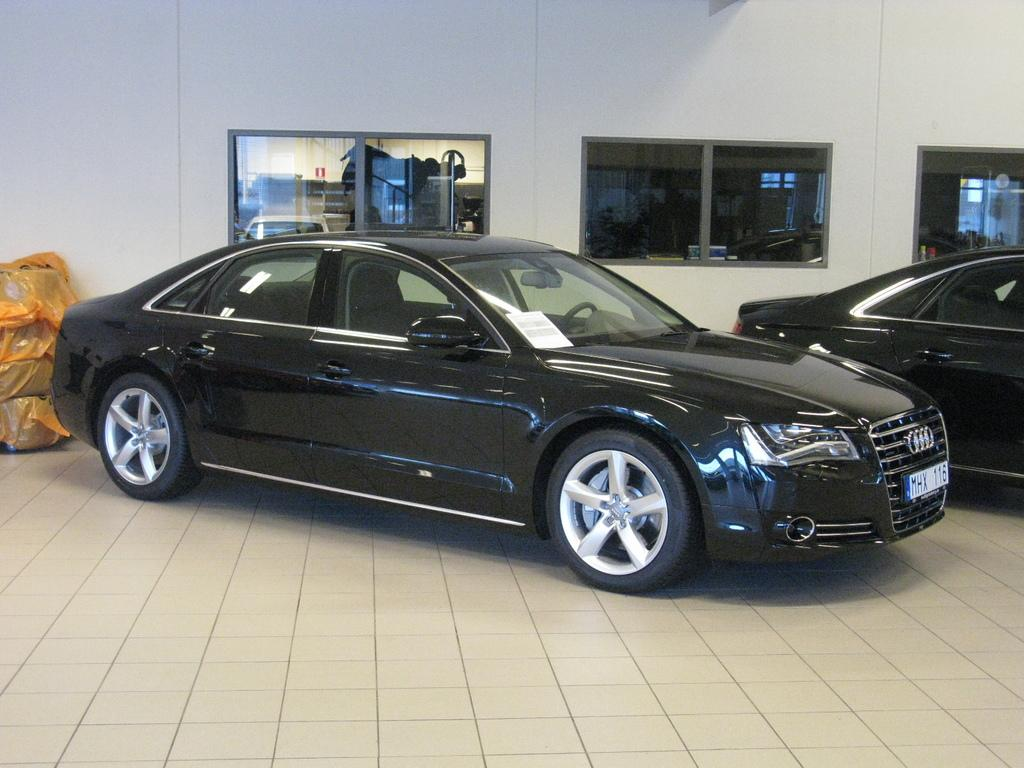What type of vehicles can be seen in the image? There are cars in the image. What other objects are present in the image besides cars? There are plastic bags and glasses in the image. Are there any masks being worn by the people in the image? There is no indication of people or masks in the image; it only features cars, plastic bags, and glasses. 